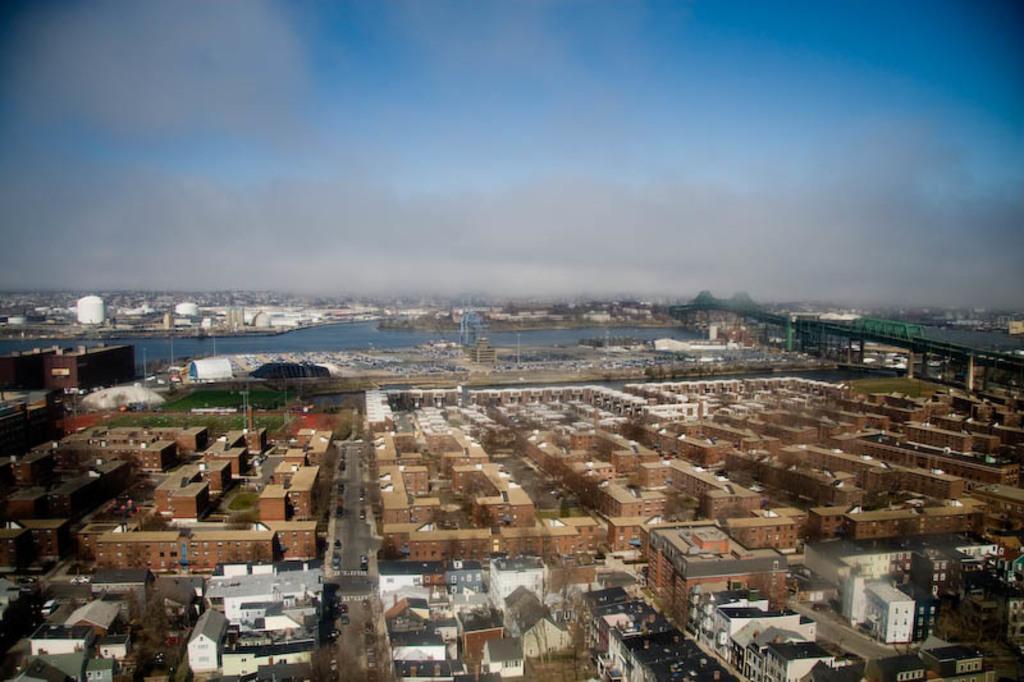Can you describe this image briefly? In this image there are some buildings at bottom of this image and there is a sky at top of this image. 